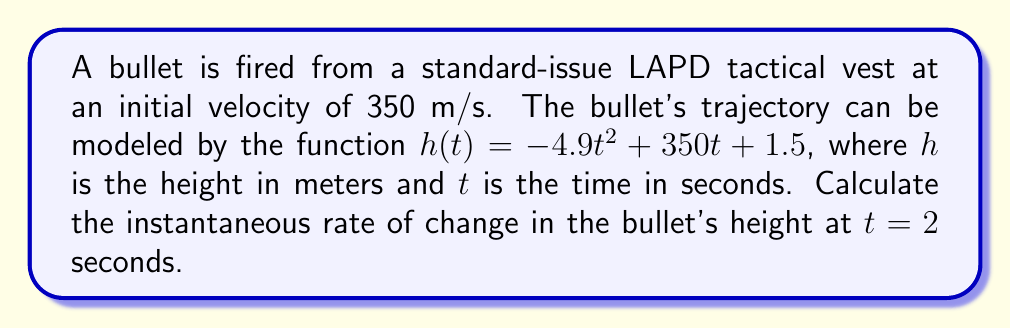Teach me how to tackle this problem. To find the instantaneous rate of change, we need to calculate the derivative of the function $h(t)$ and then evaluate it at $t = 2$ seconds.

Step 1: Find the derivative of $h(t)$.
$h(t) = -4.9t^2 + 350t + 1.5$
$h'(t) = \frac{d}{dt}(-4.9t^2 + 350t + 1.5)$
$h'(t) = -9.8t + 350$

Step 2: Evaluate $h'(t)$ at $t = 2$ seconds.
$h'(2) = -9.8(2) + 350$
$h'(2) = -19.6 + 350$
$h'(2) = 330.4$

The instantaneous rate of change at $t = 2$ seconds is 330.4 m/s.
Answer: 330.4 m/s 